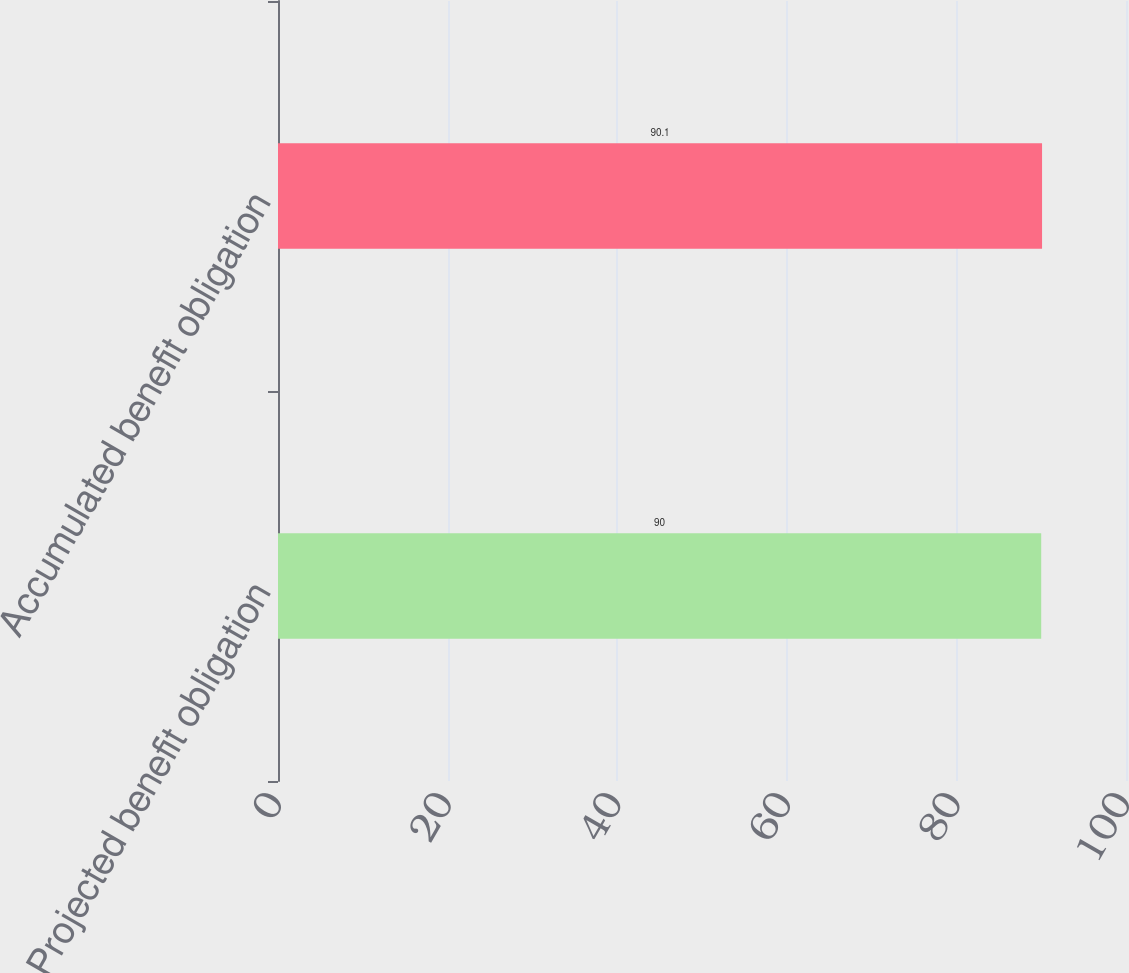<chart> <loc_0><loc_0><loc_500><loc_500><bar_chart><fcel>Projected benefit obligation<fcel>Accumulated benefit obligation<nl><fcel>90<fcel>90.1<nl></chart> 